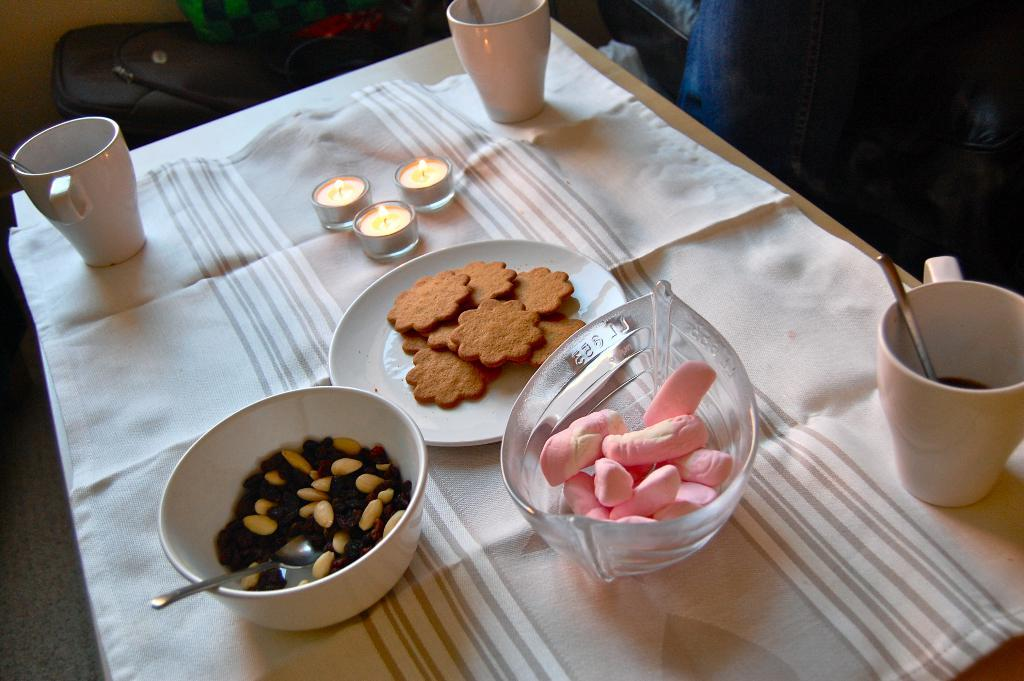What is the main piece of furniture in the image? There is a table in the image. How is the table decorated or covered? The table is covered with a white cloth. What type of food items can be seen on the table? There are cookies and a bowl containing nuts on the table. Are there any decorative elements on the table? Yes, there are three candles on the table. What type of tooth is used to crush the cookies in the image? There is no tooth present in the image, and the cookies are not being crushed. 